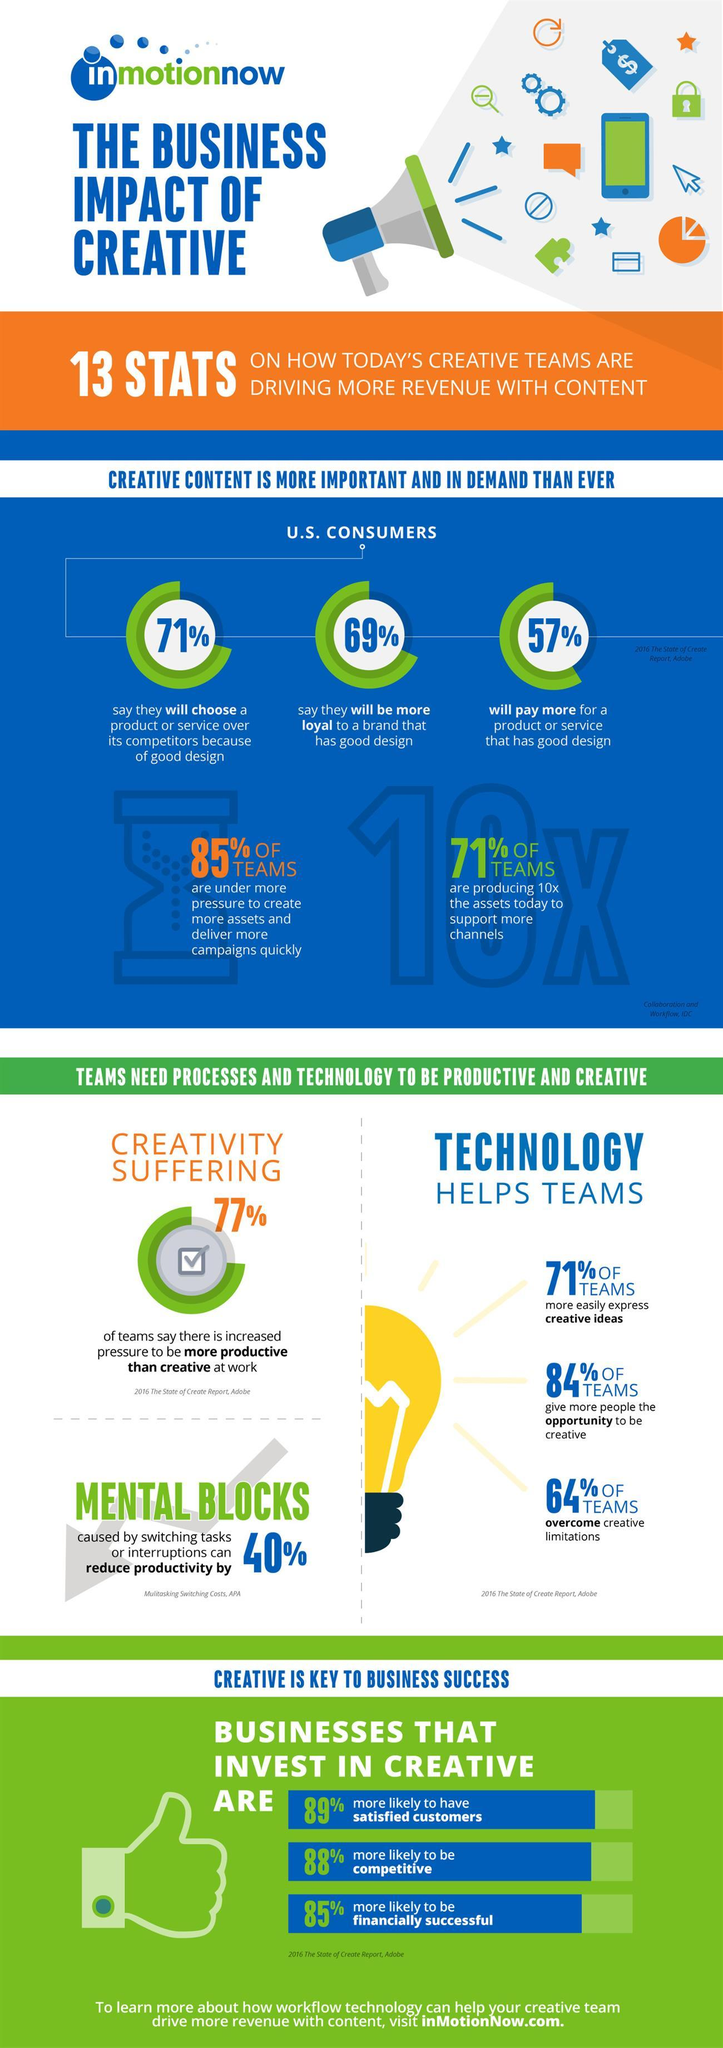Indicate a few pertinent items in this graphic. Seventy-seven percent represents creative suffering. The color of the light bulb is yellow. A study has found that 69% of consumers have brand loyalty with good design. According to a survey, 40% of people suffer from mental blocks. According to a survey, 84% of respondents believe that technology helps teams to have more opportunities to be creative. 